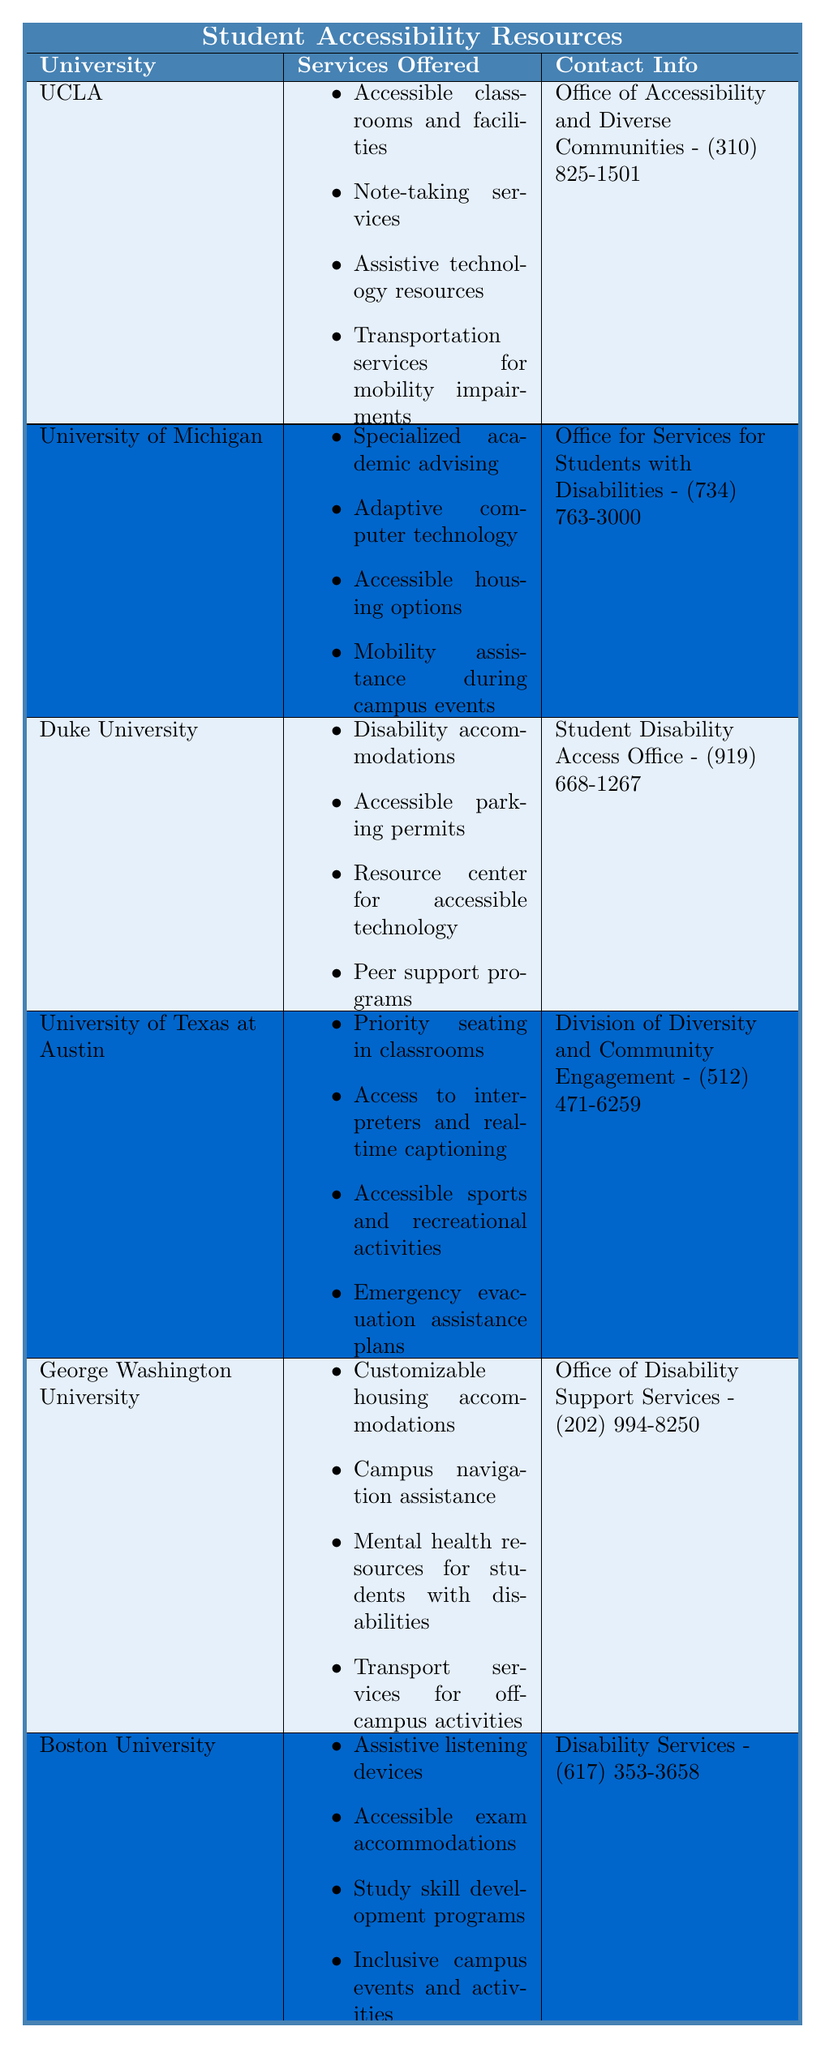What services does UCLA offer for accessibility? UCLA offers four services: accessible classrooms and facilities, note-taking services, assistive technology resources, and transportation services for students with mobility impairments.
Answer: Accessible classrooms, note-taking, assistive technology, transportation services What is the contact number for Boston University's Disability Services? The contact number for Disability Services at Boston University is (617) 353-3658.
Answer: (617) 353-3658 Does Duke University provide peer support programs? Yes, Duke University offers peer support programs as part of their accessibility resources.
Answer: Yes Which university offers access to interpreters and real-time captioning? The University of Texas at Austin offers access to interpreters and real-time captioning for students.
Answer: University of Texas at Austin How many universities provide accessible housing options? Two universities provide accessible housing options: the University of Michigan and George Washington University.
Answer: 2 What are the services offered by George Washington University? George Washington University offers customizable housing accommodations, campus navigation assistance, access to mental health resources for students with disabilities, and transport services for off-campus activities.
Answer: Customizable housing, navigation assistance, mental health resources, transport services Which university has the most services listed for accessibility? Both UCLA and the University of Texas at Austin have the most services listed with four services each.
Answer: UCLA and University of Texas at Austin Is there a university that offers assistive listening devices? Yes, Boston University provides assistive listening devices among its accessibility resources.
Answer: Yes What is the difference in the number of services offered between Duke University and Boston University? Duke University offers four services while Boston University offers four as well, so the difference is zero.
Answer: 0 What type of support does the University of Michigan provide for students with disabilities? The University of Michigan provides specialized academic advising, adaptive computer technology, accessible housing options, and mobility assistance during campus events.
Answer: Academic advising, adaptive technology, housing, mobility assistance 